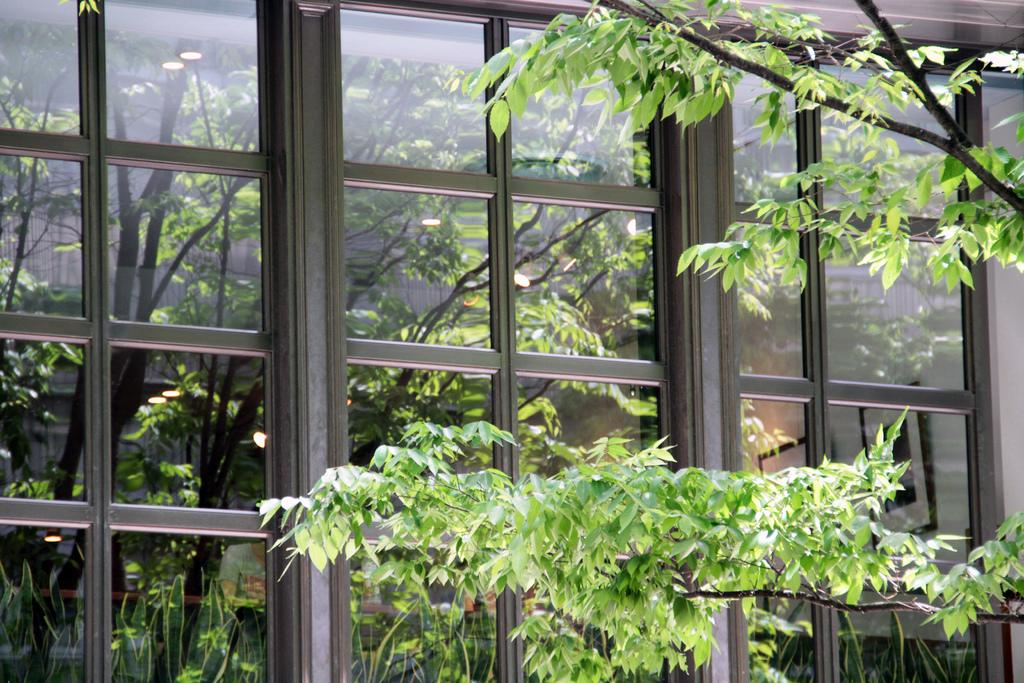What can be seen on the right side of the image? There are stems on the right side of the image. What is visible in the background of the image? There is a glass window in the background of the image. What type of joke is being told by the kitten in the image? There is no kitten present in the image, and therefore no joke being told. How many mouths can be seen in the image? There is no mouth visible in the image. 